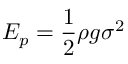Convert formula to latex. <formula><loc_0><loc_0><loc_500><loc_500>E _ { p } = { \frac { 1 } { 2 } } \rho g \sigma ^ { 2 }</formula> 